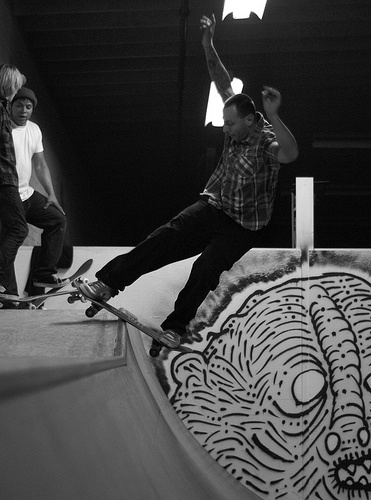Describe the objects in this image and their specific colors. I can see people in black, gray, darkgray, and lightgray tones, people in black, lightgray, gray, and darkgray tones, people in black, gray, darkgray, and lightgray tones, skateboard in black, gray, darkgray, and lightgray tones, and skateboard in black, gray, darkgray, and lightgray tones in this image. 